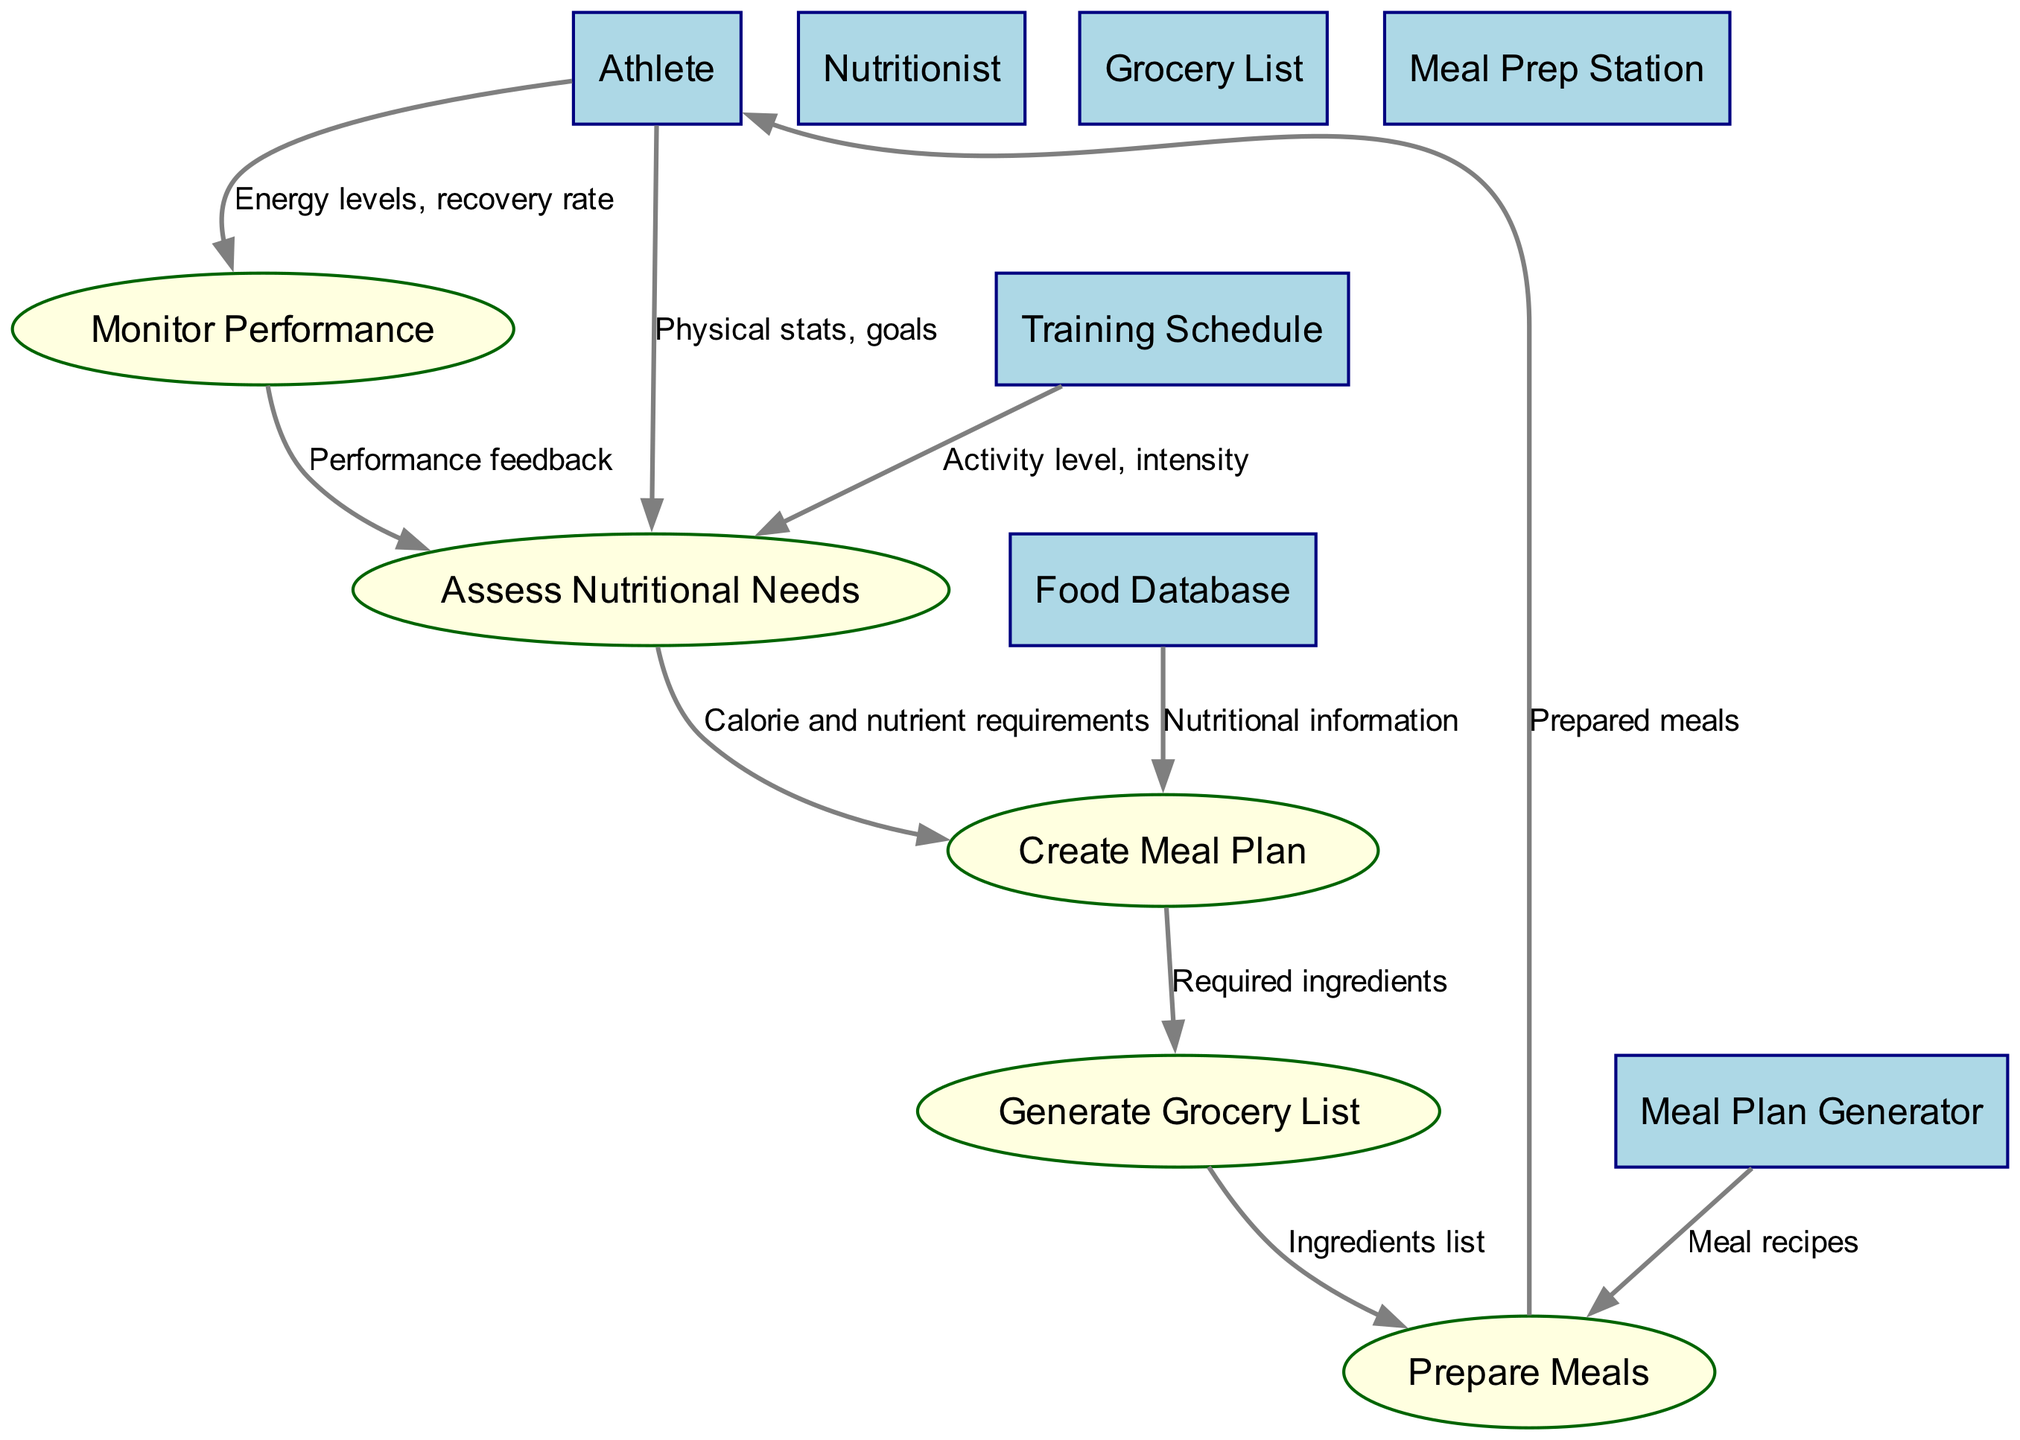What is the total number of entities in the diagram? The diagram includes six entities: Athlete, Nutritionist, Food Database, Training Schedule, Meal Plan Generator, and Grocery List.
Answer: 6 What is the output of the process "Prepare Meals"? The process "Prepare Meals" outputs "Prepared meals," which are then delivered to the Athlete.
Answer: Prepared meals Which entity provides nutritional information for creating a meal plan? The "Food Database" is the entity that provides nutritional information critical for creating a meal plan.
Answer: Food Database How many processes are there in this diagram? The diagram outlines five processes: Assess Nutritional Needs, Create Meal Plan, Generate Grocery List, Prepare Meals, and Monitor Performance.
Answer: 5 What type of feedback is used to reassess nutritional needs? "Performance feedback," based on the athlete’s energy levels and recovery rate, is used to reassess nutritional needs in the process "Assess Nutritional Needs."
Answer: Performance feedback What is the first input into the "Assess Nutritional Needs" process? The first input into the "Assess Nutritional Needs" process is "Physical stats, goals," supplied directly by the Athlete.
Answer: Physical stats, goals What data flows from "Generate Grocery List" to "Prepare Meals"? The data flowing from "Generate Grocery List" to "Prepare Meals" is labeled as "Ingredients list," which is necessary for meal preparation.
Answer: Ingredients list Which process receives data from the Training Schedule? The "Assess Nutritional Needs" process receives data from the Training Schedule, specifically the "Activity level, intensity."
Answer: Assess Nutritional Needs What type of diagram is depicted? The diagram is specifically a Data Flow Diagram, which illustrates the flow of information and processes related to nutrition planning for athletes.
Answer: Data Flow Diagram 